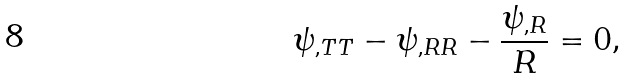Convert formula to latex. <formula><loc_0><loc_0><loc_500><loc_500>\psi _ { , T T } - \psi _ { , R R } - \frac { \psi _ { , R } } { R } = 0 ,</formula> 